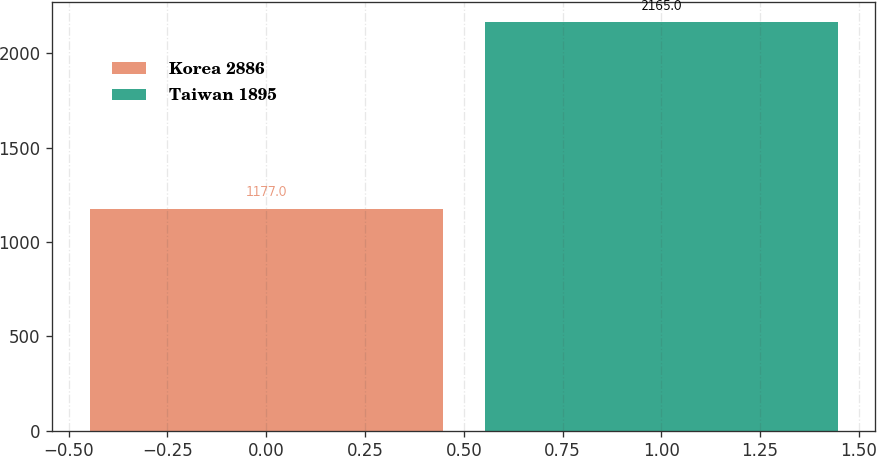Convert chart to OTSL. <chart><loc_0><loc_0><loc_500><loc_500><bar_chart><fcel>Korea 2886<fcel>Taiwan 1895<nl><fcel>1177<fcel>2165<nl></chart> 